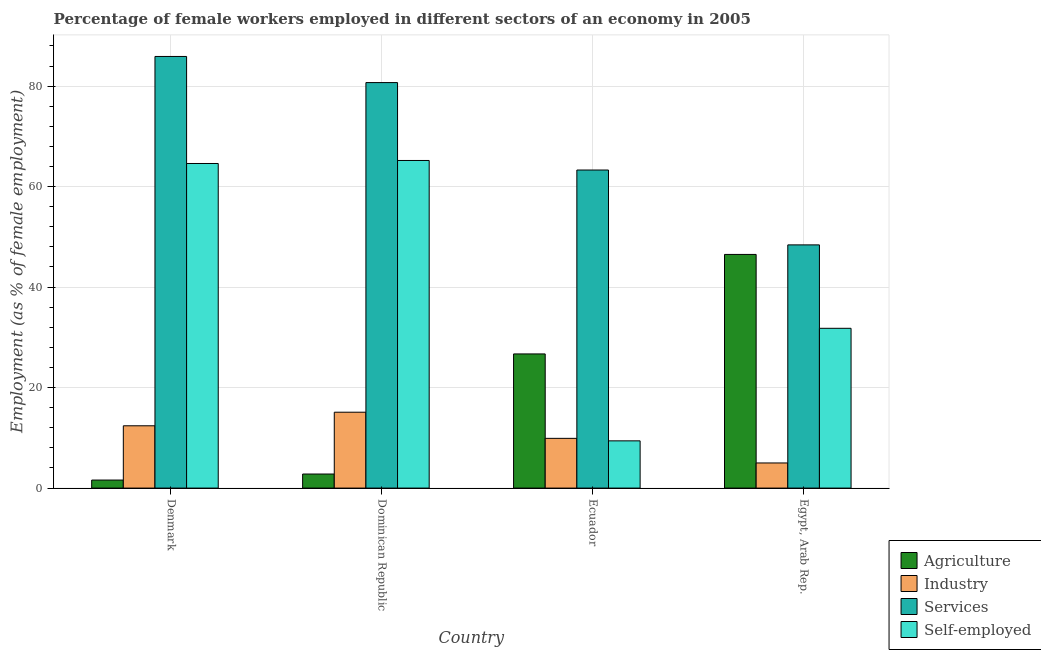How many different coloured bars are there?
Your answer should be very brief. 4. How many groups of bars are there?
Your answer should be very brief. 4. Are the number of bars per tick equal to the number of legend labels?
Ensure brevity in your answer.  Yes. How many bars are there on the 4th tick from the left?
Your response must be concise. 4. What is the label of the 4th group of bars from the left?
Your answer should be very brief. Egypt, Arab Rep. What is the percentage of female workers in agriculture in Denmark?
Your answer should be compact. 1.6. Across all countries, what is the maximum percentage of self employed female workers?
Give a very brief answer. 65.2. Across all countries, what is the minimum percentage of female workers in services?
Ensure brevity in your answer.  48.4. In which country was the percentage of female workers in agriculture maximum?
Your response must be concise. Egypt, Arab Rep. In which country was the percentage of female workers in agriculture minimum?
Keep it short and to the point. Denmark. What is the total percentage of self employed female workers in the graph?
Make the answer very short. 171. What is the difference between the percentage of female workers in agriculture in Denmark and that in Ecuador?
Offer a terse response. -25.1. What is the difference between the percentage of self employed female workers in Ecuador and the percentage of female workers in agriculture in Dominican Republic?
Offer a very short reply. 6.6. What is the average percentage of female workers in industry per country?
Ensure brevity in your answer.  10.6. What is the difference between the percentage of female workers in industry and percentage of female workers in services in Dominican Republic?
Keep it short and to the point. -65.6. In how many countries, is the percentage of female workers in industry greater than 44 %?
Provide a short and direct response. 0. What is the ratio of the percentage of female workers in industry in Denmark to that in Egypt, Arab Rep.?
Ensure brevity in your answer.  2.48. Is the percentage of female workers in services in Denmark less than that in Dominican Republic?
Keep it short and to the point. No. Is the difference between the percentage of female workers in services in Denmark and Ecuador greater than the difference between the percentage of female workers in agriculture in Denmark and Ecuador?
Ensure brevity in your answer.  Yes. What is the difference between the highest and the second highest percentage of female workers in agriculture?
Provide a succinct answer. 19.8. What is the difference between the highest and the lowest percentage of female workers in industry?
Your response must be concise. 10.1. Is the sum of the percentage of female workers in industry in Ecuador and Egypt, Arab Rep. greater than the maximum percentage of female workers in services across all countries?
Make the answer very short. No. What does the 1st bar from the left in Ecuador represents?
Offer a very short reply. Agriculture. What does the 2nd bar from the right in Ecuador represents?
Offer a very short reply. Services. Is it the case that in every country, the sum of the percentage of female workers in agriculture and percentage of female workers in industry is greater than the percentage of female workers in services?
Your answer should be compact. No. How many countries are there in the graph?
Make the answer very short. 4. What is the difference between two consecutive major ticks on the Y-axis?
Provide a succinct answer. 20. Are the values on the major ticks of Y-axis written in scientific E-notation?
Your answer should be very brief. No. Does the graph contain grids?
Offer a very short reply. Yes. Where does the legend appear in the graph?
Offer a very short reply. Bottom right. How are the legend labels stacked?
Make the answer very short. Vertical. What is the title of the graph?
Give a very brief answer. Percentage of female workers employed in different sectors of an economy in 2005. What is the label or title of the Y-axis?
Provide a short and direct response. Employment (as % of female employment). What is the Employment (as % of female employment) of Agriculture in Denmark?
Your answer should be compact. 1.6. What is the Employment (as % of female employment) of Industry in Denmark?
Make the answer very short. 12.4. What is the Employment (as % of female employment) of Services in Denmark?
Offer a terse response. 85.9. What is the Employment (as % of female employment) of Self-employed in Denmark?
Give a very brief answer. 64.6. What is the Employment (as % of female employment) of Agriculture in Dominican Republic?
Provide a succinct answer. 2.8. What is the Employment (as % of female employment) of Industry in Dominican Republic?
Make the answer very short. 15.1. What is the Employment (as % of female employment) of Services in Dominican Republic?
Provide a succinct answer. 80.7. What is the Employment (as % of female employment) in Self-employed in Dominican Republic?
Give a very brief answer. 65.2. What is the Employment (as % of female employment) of Agriculture in Ecuador?
Give a very brief answer. 26.7. What is the Employment (as % of female employment) in Industry in Ecuador?
Your response must be concise. 9.9. What is the Employment (as % of female employment) of Services in Ecuador?
Offer a very short reply. 63.3. What is the Employment (as % of female employment) of Self-employed in Ecuador?
Your response must be concise. 9.4. What is the Employment (as % of female employment) in Agriculture in Egypt, Arab Rep.?
Your answer should be very brief. 46.5. What is the Employment (as % of female employment) of Industry in Egypt, Arab Rep.?
Ensure brevity in your answer.  5. What is the Employment (as % of female employment) in Services in Egypt, Arab Rep.?
Keep it short and to the point. 48.4. What is the Employment (as % of female employment) in Self-employed in Egypt, Arab Rep.?
Provide a succinct answer. 31.8. Across all countries, what is the maximum Employment (as % of female employment) of Agriculture?
Ensure brevity in your answer.  46.5. Across all countries, what is the maximum Employment (as % of female employment) in Industry?
Ensure brevity in your answer.  15.1. Across all countries, what is the maximum Employment (as % of female employment) of Services?
Your response must be concise. 85.9. Across all countries, what is the maximum Employment (as % of female employment) in Self-employed?
Keep it short and to the point. 65.2. Across all countries, what is the minimum Employment (as % of female employment) in Agriculture?
Make the answer very short. 1.6. Across all countries, what is the minimum Employment (as % of female employment) in Services?
Your response must be concise. 48.4. Across all countries, what is the minimum Employment (as % of female employment) of Self-employed?
Your answer should be compact. 9.4. What is the total Employment (as % of female employment) of Agriculture in the graph?
Keep it short and to the point. 77.6. What is the total Employment (as % of female employment) of Industry in the graph?
Your answer should be very brief. 42.4. What is the total Employment (as % of female employment) in Services in the graph?
Your answer should be compact. 278.3. What is the total Employment (as % of female employment) in Self-employed in the graph?
Make the answer very short. 171. What is the difference between the Employment (as % of female employment) in Agriculture in Denmark and that in Dominican Republic?
Provide a short and direct response. -1.2. What is the difference between the Employment (as % of female employment) of Agriculture in Denmark and that in Ecuador?
Give a very brief answer. -25.1. What is the difference between the Employment (as % of female employment) of Industry in Denmark and that in Ecuador?
Offer a terse response. 2.5. What is the difference between the Employment (as % of female employment) in Services in Denmark and that in Ecuador?
Your response must be concise. 22.6. What is the difference between the Employment (as % of female employment) of Self-employed in Denmark and that in Ecuador?
Make the answer very short. 55.2. What is the difference between the Employment (as % of female employment) in Agriculture in Denmark and that in Egypt, Arab Rep.?
Provide a succinct answer. -44.9. What is the difference between the Employment (as % of female employment) in Services in Denmark and that in Egypt, Arab Rep.?
Keep it short and to the point. 37.5. What is the difference between the Employment (as % of female employment) in Self-employed in Denmark and that in Egypt, Arab Rep.?
Offer a very short reply. 32.8. What is the difference between the Employment (as % of female employment) of Agriculture in Dominican Republic and that in Ecuador?
Make the answer very short. -23.9. What is the difference between the Employment (as % of female employment) of Self-employed in Dominican Republic and that in Ecuador?
Your response must be concise. 55.8. What is the difference between the Employment (as % of female employment) of Agriculture in Dominican Republic and that in Egypt, Arab Rep.?
Make the answer very short. -43.7. What is the difference between the Employment (as % of female employment) in Industry in Dominican Republic and that in Egypt, Arab Rep.?
Your response must be concise. 10.1. What is the difference between the Employment (as % of female employment) in Services in Dominican Republic and that in Egypt, Arab Rep.?
Make the answer very short. 32.3. What is the difference between the Employment (as % of female employment) in Self-employed in Dominican Republic and that in Egypt, Arab Rep.?
Ensure brevity in your answer.  33.4. What is the difference between the Employment (as % of female employment) of Agriculture in Ecuador and that in Egypt, Arab Rep.?
Your answer should be very brief. -19.8. What is the difference between the Employment (as % of female employment) in Industry in Ecuador and that in Egypt, Arab Rep.?
Your answer should be very brief. 4.9. What is the difference between the Employment (as % of female employment) in Services in Ecuador and that in Egypt, Arab Rep.?
Your answer should be compact. 14.9. What is the difference between the Employment (as % of female employment) of Self-employed in Ecuador and that in Egypt, Arab Rep.?
Ensure brevity in your answer.  -22.4. What is the difference between the Employment (as % of female employment) of Agriculture in Denmark and the Employment (as % of female employment) of Industry in Dominican Republic?
Offer a very short reply. -13.5. What is the difference between the Employment (as % of female employment) in Agriculture in Denmark and the Employment (as % of female employment) in Services in Dominican Republic?
Your response must be concise. -79.1. What is the difference between the Employment (as % of female employment) in Agriculture in Denmark and the Employment (as % of female employment) in Self-employed in Dominican Republic?
Provide a short and direct response. -63.6. What is the difference between the Employment (as % of female employment) in Industry in Denmark and the Employment (as % of female employment) in Services in Dominican Republic?
Your answer should be very brief. -68.3. What is the difference between the Employment (as % of female employment) of Industry in Denmark and the Employment (as % of female employment) of Self-employed in Dominican Republic?
Make the answer very short. -52.8. What is the difference between the Employment (as % of female employment) in Services in Denmark and the Employment (as % of female employment) in Self-employed in Dominican Republic?
Provide a succinct answer. 20.7. What is the difference between the Employment (as % of female employment) in Agriculture in Denmark and the Employment (as % of female employment) in Industry in Ecuador?
Provide a succinct answer. -8.3. What is the difference between the Employment (as % of female employment) of Agriculture in Denmark and the Employment (as % of female employment) of Services in Ecuador?
Offer a terse response. -61.7. What is the difference between the Employment (as % of female employment) in Agriculture in Denmark and the Employment (as % of female employment) in Self-employed in Ecuador?
Provide a short and direct response. -7.8. What is the difference between the Employment (as % of female employment) of Industry in Denmark and the Employment (as % of female employment) of Services in Ecuador?
Your answer should be very brief. -50.9. What is the difference between the Employment (as % of female employment) in Industry in Denmark and the Employment (as % of female employment) in Self-employed in Ecuador?
Keep it short and to the point. 3. What is the difference between the Employment (as % of female employment) of Services in Denmark and the Employment (as % of female employment) of Self-employed in Ecuador?
Keep it short and to the point. 76.5. What is the difference between the Employment (as % of female employment) in Agriculture in Denmark and the Employment (as % of female employment) in Industry in Egypt, Arab Rep.?
Keep it short and to the point. -3.4. What is the difference between the Employment (as % of female employment) of Agriculture in Denmark and the Employment (as % of female employment) of Services in Egypt, Arab Rep.?
Offer a terse response. -46.8. What is the difference between the Employment (as % of female employment) of Agriculture in Denmark and the Employment (as % of female employment) of Self-employed in Egypt, Arab Rep.?
Your response must be concise. -30.2. What is the difference between the Employment (as % of female employment) in Industry in Denmark and the Employment (as % of female employment) in Services in Egypt, Arab Rep.?
Offer a terse response. -36. What is the difference between the Employment (as % of female employment) in Industry in Denmark and the Employment (as % of female employment) in Self-employed in Egypt, Arab Rep.?
Ensure brevity in your answer.  -19.4. What is the difference between the Employment (as % of female employment) in Services in Denmark and the Employment (as % of female employment) in Self-employed in Egypt, Arab Rep.?
Your response must be concise. 54.1. What is the difference between the Employment (as % of female employment) in Agriculture in Dominican Republic and the Employment (as % of female employment) in Services in Ecuador?
Make the answer very short. -60.5. What is the difference between the Employment (as % of female employment) of Agriculture in Dominican Republic and the Employment (as % of female employment) of Self-employed in Ecuador?
Your answer should be compact. -6.6. What is the difference between the Employment (as % of female employment) in Industry in Dominican Republic and the Employment (as % of female employment) in Services in Ecuador?
Offer a terse response. -48.2. What is the difference between the Employment (as % of female employment) of Services in Dominican Republic and the Employment (as % of female employment) of Self-employed in Ecuador?
Give a very brief answer. 71.3. What is the difference between the Employment (as % of female employment) of Agriculture in Dominican Republic and the Employment (as % of female employment) of Services in Egypt, Arab Rep.?
Offer a terse response. -45.6. What is the difference between the Employment (as % of female employment) in Industry in Dominican Republic and the Employment (as % of female employment) in Services in Egypt, Arab Rep.?
Offer a very short reply. -33.3. What is the difference between the Employment (as % of female employment) of Industry in Dominican Republic and the Employment (as % of female employment) of Self-employed in Egypt, Arab Rep.?
Keep it short and to the point. -16.7. What is the difference between the Employment (as % of female employment) in Services in Dominican Republic and the Employment (as % of female employment) in Self-employed in Egypt, Arab Rep.?
Provide a short and direct response. 48.9. What is the difference between the Employment (as % of female employment) in Agriculture in Ecuador and the Employment (as % of female employment) in Industry in Egypt, Arab Rep.?
Your response must be concise. 21.7. What is the difference between the Employment (as % of female employment) in Agriculture in Ecuador and the Employment (as % of female employment) in Services in Egypt, Arab Rep.?
Provide a succinct answer. -21.7. What is the difference between the Employment (as % of female employment) in Agriculture in Ecuador and the Employment (as % of female employment) in Self-employed in Egypt, Arab Rep.?
Make the answer very short. -5.1. What is the difference between the Employment (as % of female employment) in Industry in Ecuador and the Employment (as % of female employment) in Services in Egypt, Arab Rep.?
Offer a very short reply. -38.5. What is the difference between the Employment (as % of female employment) in Industry in Ecuador and the Employment (as % of female employment) in Self-employed in Egypt, Arab Rep.?
Offer a very short reply. -21.9. What is the difference between the Employment (as % of female employment) in Services in Ecuador and the Employment (as % of female employment) in Self-employed in Egypt, Arab Rep.?
Your response must be concise. 31.5. What is the average Employment (as % of female employment) in Agriculture per country?
Make the answer very short. 19.4. What is the average Employment (as % of female employment) in Industry per country?
Your answer should be compact. 10.6. What is the average Employment (as % of female employment) of Services per country?
Your answer should be compact. 69.58. What is the average Employment (as % of female employment) in Self-employed per country?
Give a very brief answer. 42.75. What is the difference between the Employment (as % of female employment) of Agriculture and Employment (as % of female employment) of Services in Denmark?
Your response must be concise. -84.3. What is the difference between the Employment (as % of female employment) of Agriculture and Employment (as % of female employment) of Self-employed in Denmark?
Ensure brevity in your answer.  -63. What is the difference between the Employment (as % of female employment) in Industry and Employment (as % of female employment) in Services in Denmark?
Provide a short and direct response. -73.5. What is the difference between the Employment (as % of female employment) in Industry and Employment (as % of female employment) in Self-employed in Denmark?
Keep it short and to the point. -52.2. What is the difference between the Employment (as % of female employment) in Services and Employment (as % of female employment) in Self-employed in Denmark?
Your response must be concise. 21.3. What is the difference between the Employment (as % of female employment) in Agriculture and Employment (as % of female employment) in Industry in Dominican Republic?
Give a very brief answer. -12.3. What is the difference between the Employment (as % of female employment) of Agriculture and Employment (as % of female employment) of Services in Dominican Republic?
Your response must be concise. -77.9. What is the difference between the Employment (as % of female employment) in Agriculture and Employment (as % of female employment) in Self-employed in Dominican Republic?
Provide a succinct answer. -62.4. What is the difference between the Employment (as % of female employment) of Industry and Employment (as % of female employment) of Services in Dominican Republic?
Your answer should be compact. -65.6. What is the difference between the Employment (as % of female employment) in Industry and Employment (as % of female employment) in Self-employed in Dominican Republic?
Give a very brief answer. -50.1. What is the difference between the Employment (as % of female employment) of Agriculture and Employment (as % of female employment) of Industry in Ecuador?
Give a very brief answer. 16.8. What is the difference between the Employment (as % of female employment) of Agriculture and Employment (as % of female employment) of Services in Ecuador?
Make the answer very short. -36.6. What is the difference between the Employment (as % of female employment) of Industry and Employment (as % of female employment) of Services in Ecuador?
Provide a short and direct response. -53.4. What is the difference between the Employment (as % of female employment) of Industry and Employment (as % of female employment) of Self-employed in Ecuador?
Make the answer very short. 0.5. What is the difference between the Employment (as % of female employment) of Services and Employment (as % of female employment) of Self-employed in Ecuador?
Keep it short and to the point. 53.9. What is the difference between the Employment (as % of female employment) in Agriculture and Employment (as % of female employment) in Industry in Egypt, Arab Rep.?
Your answer should be compact. 41.5. What is the difference between the Employment (as % of female employment) of Agriculture and Employment (as % of female employment) of Self-employed in Egypt, Arab Rep.?
Your answer should be very brief. 14.7. What is the difference between the Employment (as % of female employment) of Industry and Employment (as % of female employment) of Services in Egypt, Arab Rep.?
Your answer should be compact. -43.4. What is the difference between the Employment (as % of female employment) of Industry and Employment (as % of female employment) of Self-employed in Egypt, Arab Rep.?
Give a very brief answer. -26.8. What is the difference between the Employment (as % of female employment) of Services and Employment (as % of female employment) of Self-employed in Egypt, Arab Rep.?
Provide a short and direct response. 16.6. What is the ratio of the Employment (as % of female employment) in Industry in Denmark to that in Dominican Republic?
Your answer should be compact. 0.82. What is the ratio of the Employment (as % of female employment) in Services in Denmark to that in Dominican Republic?
Make the answer very short. 1.06. What is the ratio of the Employment (as % of female employment) of Agriculture in Denmark to that in Ecuador?
Offer a terse response. 0.06. What is the ratio of the Employment (as % of female employment) of Industry in Denmark to that in Ecuador?
Make the answer very short. 1.25. What is the ratio of the Employment (as % of female employment) in Services in Denmark to that in Ecuador?
Your response must be concise. 1.36. What is the ratio of the Employment (as % of female employment) in Self-employed in Denmark to that in Ecuador?
Make the answer very short. 6.87. What is the ratio of the Employment (as % of female employment) in Agriculture in Denmark to that in Egypt, Arab Rep.?
Make the answer very short. 0.03. What is the ratio of the Employment (as % of female employment) in Industry in Denmark to that in Egypt, Arab Rep.?
Offer a terse response. 2.48. What is the ratio of the Employment (as % of female employment) of Services in Denmark to that in Egypt, Arab Rep.?
Give a very brief answer. 1.77. What is the ratio of the Employment (as % of female employment) of Self-employed in Denmark to that in Egypt, Arab Rep.?
Provide a short and direct response. 2.03. What is the ratio of the Employment (as % of female employment) of Agriculture in Dominican Republic to that in Ecuador?
Provide a short and direct response. 0.1. What is the ratio of the Employment (as % of female employment) in Industry in Dominican Republic to that in Ecuador?
Ensure brevity in your answer.  1.53. What is the ratio of the Employment (as % of female employment) of Services in Dominican Republic to that in Ecuador?
Provide a short and direct response. 1.27. What is the ratio of the Employment (as % of female employment) of Self-employed in Dominican Republic to that in Ecuador?
Provide a short and direct response. 6.94. What is the ratio of the Employment (as % of female employment) of Agriculture in Dominican Republic to that in Egypt, Arab Rep.?
Provide a short and direct response. 0.06. What is the ratio of the Employment (as % of female employment) of Industry in Dominican Republic to that in Egypt, Arab Rep.?
Make the answer very short. 3.02. What is the ratio of the Employment (as % of female employment) of Services in Dominican Republic to that in Egypt, Arab Rep.?
Your response must be concise. 1.67. What is the ratio of the Employment (as % of female employment) in Self-employed in Dominican Republic to that in Egypt, Arab Rep.?
Provide a short and direct response. 2.05. What is the ratio of the Employment (as % of female employment) of Agriculture in Ecuador to that in Egypt, Arab Rep.?
Keep it short and to the point. 0.57. What is the ratio of the Employment (as % of female employment) of Industry in Ecuador to that in Egypt, Arab Rep.?
Provide a succinct answer. 1.98. What is the ratio of the Employment (as % of female employment) of Services in Ecuador to that in Egypt, Arab Rep.?
Your response must be concise. 1.31. What is the ratio of the Employment (as % of female employment) of Self-employed in Ecuador to that in Egypt, Arab Rep.?
Offer a terse response. 0.3. What is the difference between the highest and the second highest Employment (as % of female employment) of Agriculture?
Keep it short and to the point. 19.8. What is the difference between the highest and the second highest Employment (as % of female employment) of Industry?
Ensure brevity in your answer.  2.7. What is the difference between the highest and the second highest Employment (as % of female employment) in Self-employed?
Offer a terse response. 0.6. What is the difference between the highest and the lowest Employment (as % of female employment) in Agriculture?
Make the answer very short. 44.9. What is the difference between the highest and the lowest Employment (as % of female employment) of Industry?
Provide a succinct answer. 10.1. What is the difference between the highest and the lowest Employment (as % of female employment) in Services?
Make the answer very short. 37.5. What is the difference between the highest and the lowest Employment (as % of female employment) in Self-employed?
Keep it short and to the point. 55.8. 